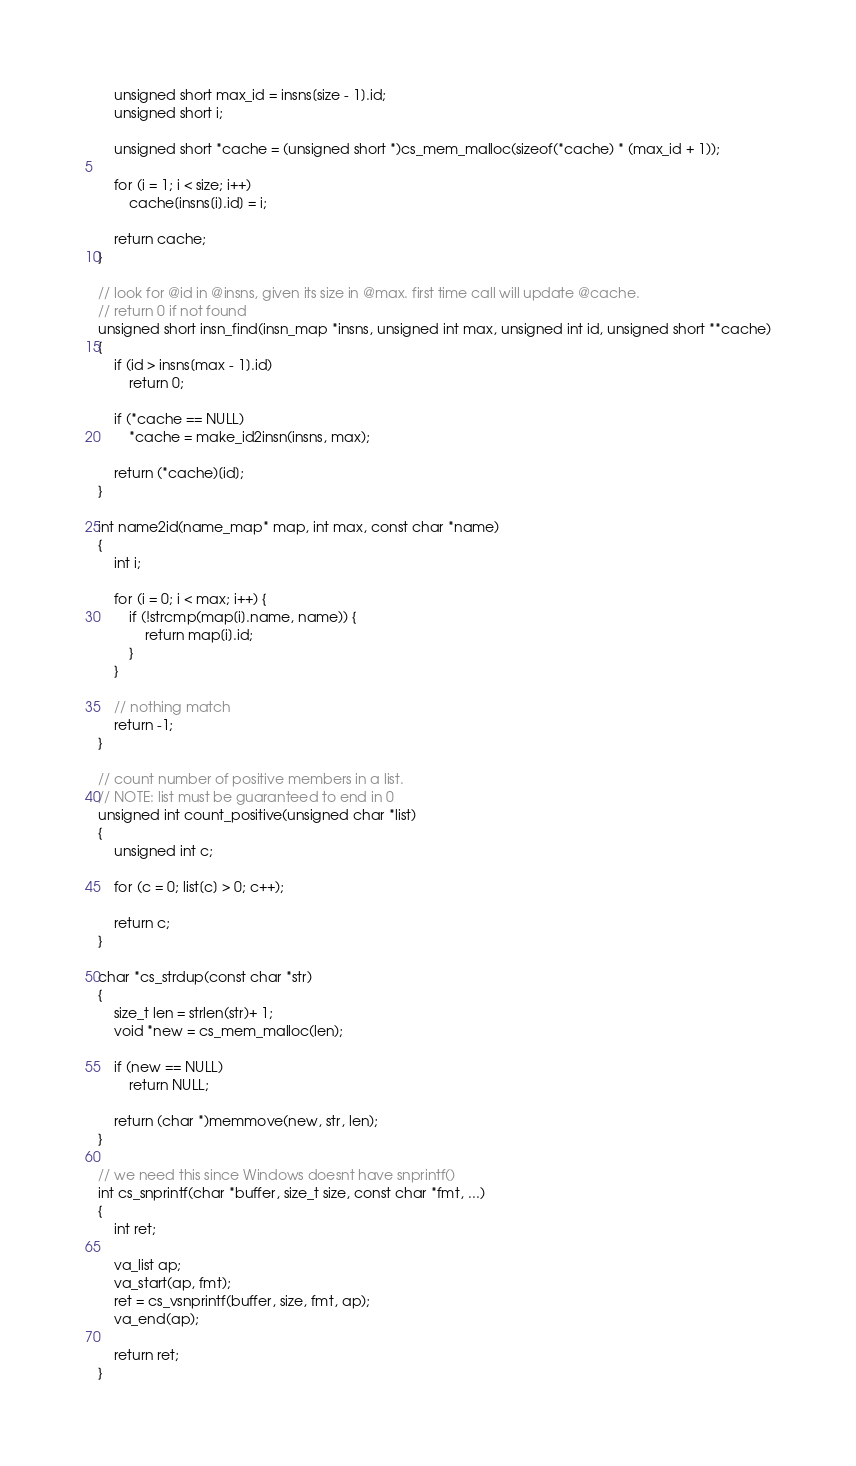<code> <loc_0><loc_0><loc_500><loc_500><_C_>	unsigned short max_id = insns[size - 1].id;
	unsigned short i;

	unsigned short *cache = (unsigned short *)cs_mem_malloc(sizeof(*cache) * (max_id + 1));

	for (i = 1; i < size; i++)
		cache[insns[i].id] = i;

	return cache;
}

// look for @id in @insns, given its size in @max. first time call will update @cache.
// return 0 if not found
unsigned short insn_find(insn_map *insns, unsigned int max, unsigned int id, unsigned short **cache)
{
	if (id > insns[max - 1].id)
		return 0;

	if (*cache == NULL)
		*cache = make_id2insn(insns, max);

	return (*cache)[id];
}

int name2id(name_map* map, int max, const char *name)
{
	int i;

	for (i = 0; i < max; i++) {
		if (!strcmp(map[i].name, name)) {
			return map[i].id;
		}
	}

	// nothing match
	return -1;
}

// count number of positive members in a list.
// NOTE: list must be guaranteed to end in 0
unsigned int count_positive(unsigned char *list)
{
	unsigned int c;

	for (c = 0; list[c] > 0; c++);

	return c;
}

char *cs_strdup(const char *str)
{
	size_t len = strlen(str)+ 1;
	void *new = cs_mem_malloc(len);

	if (new == NULL)
		return NULL;

	return (char *)memmove(new, str, len);
}

// we need this since Windows doesnt have snprintf()
int cs_snprintf(char *buffer, size_t size, const char *fmt, ...)
{
	int ret;

	va_list ap;
	va_start(ap, fmt);
	ret = cs_vsnprintf(buffer, size, fmt, ap);
	va_end(ap);

	return ret;
}
</code> 